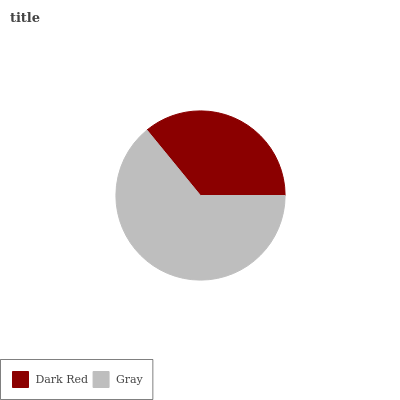Is Dark Red the minimum?
Answer yes or no. Yes. Is Gray the maximum?
Answer yes or no. Yes. Is Gray the minimum?
Answer yes or no. No. Is Gray greater than Dark Red?
Answer yes or no. Yes. Is Dark Red less than Gray?
Answer yes or no. Yes. Is Dark Red greater than Gray?
Answer yes or no. No. Is Gray less than Dark Red?
Answer yes or no. No. Is Gray the high median?
Answer yes or no. Yes. Is Dark Red the low median?
Answer yes or no. Yes. Is Dark Red the high median?
Answer yes or no. No. Is Gray the low median?
Answer yes or no. No. 